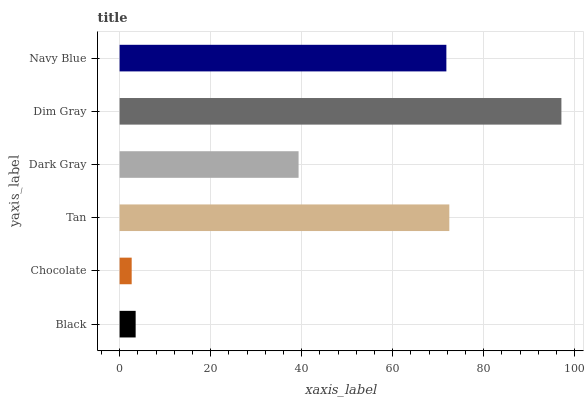Is Chocolate the minimum?
Answer yes or no. Yes. Is Dim Gray the maximum?
Answer yes or no. Yes. Is Tan the minimum?
Answer yes or no. No. Is Tan the maximum?
Answer yes or no. No. Is Tan greater than Chocolate?
Answer yes or no. Yes. Is Chocolate less than Tan?
Answer yes or no. Yes. Is Chocolate greater than Tan?
Answer yes or no. No. Is Tan less than Chocolate?
Answer yes or no. No. Is Navy Blue the high median?
Answer yes or no. Yes. Is Dark Gray the low median?
Answer yes or no. Yes. Is Tan the high median?
Answer yes or no. No. Is Black the low median?
Answer yes or no. No. 